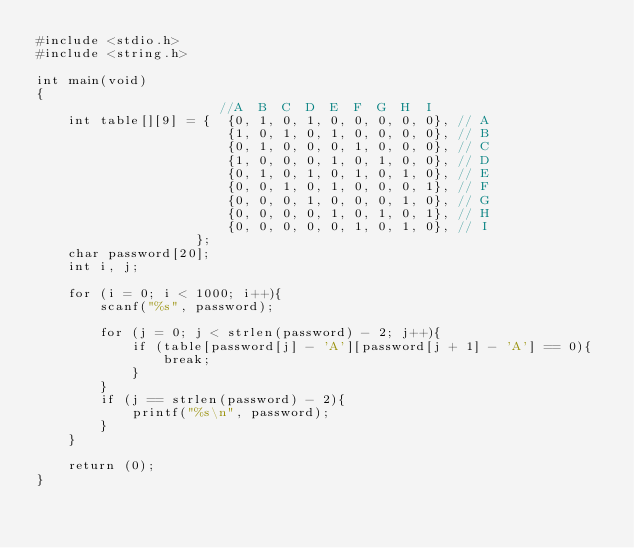<code> <loc_0><loc_0><loc_500><loc_500><_C_>#include <stdio.h>
#include <string.h>

int main(void)
{
                       //A  B  C  D  E  F  G  H  I 
    int table[][9] = {  {0, 1, 0, 1, 0, 0, 0, 0, 0}, // A
                        {1, 0, 1, 0, 1, 0, 0, 0, 0}, // B
                        {0, 1, 0, 0, 0, 1, 0, 0, 0}, // C
                        {1, 0, 0, 0, 1, 0, 1, 0, 0}, // D
                        {0, 1, 0, 1, 0, 1, 0, 1, 0}, // E
                        {0, 0, 1, 0, 1, 0, 0, 0, 1}, // F
                        {0, 0, 0, 1, 0, 0, 0, 1, 0}, // G
                        {0, 0, 0, 0, 1, 0, 1, 0, 1}, // H
                        {0, 0, 0, 0, 0, 1, 0, 1, 0}, // I
                    };
    char password[20];
    int i, j;
    
    for (i = 0; i < 1000; i++){
        scanf("%s", password);
        
        for (j = 0; j < strlen(password) - 2; j++){
            if (table[password[j] - 'A'][password[j + 1] - 'A'] == 0){
                break;
            }
        }
        if (j == strlen(password) - 2){
            printf("%s\n", password);
        }
    }
    
    return (0);
}
 </code> 